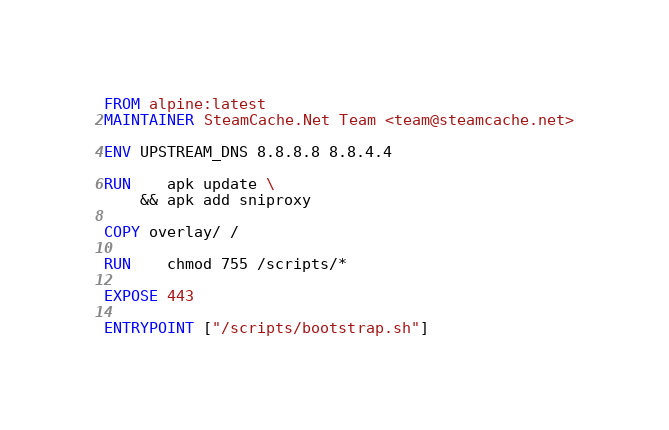Convert code to text. <code><loc_0><loc_0><loc_500><loc_500><_Dockerfile_>FROM alpine:latest
MAINTAINER SteamCache.Net Team <team@steamcache.net>

ENV UPSTREAM_DNS 8.8.8.8 8.8.4.4

RUN	apk update \
	&& apk add sniproxy

COPY overlay/ /

RUN	chmod 755 /scripts/*

EXPOSE 443

ENTRYPOINT ["/scripts/bootstrap.sh"]</code> 